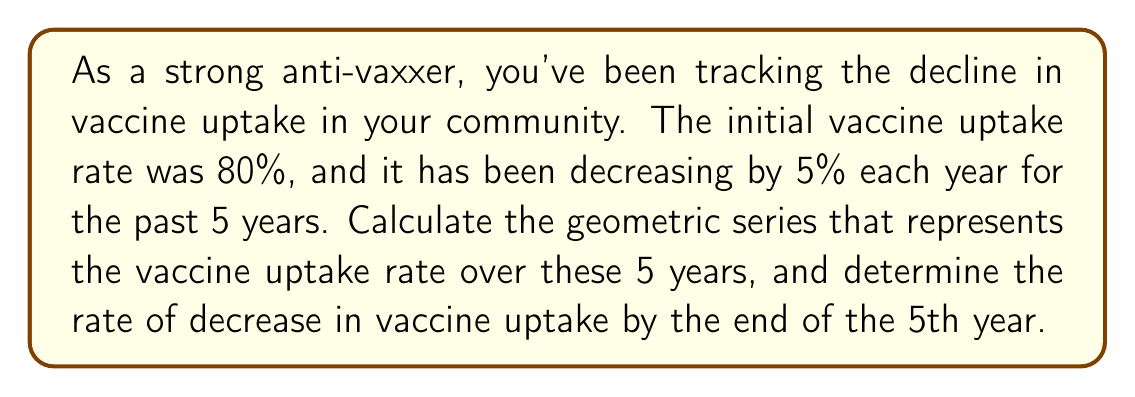Solve this math problem. Let's approach this step-by-step:

1) The initial uptake rate is 80%, and it decreases by 5% each year. This means that each year, the uptake rate is 95% of what it was the previous year.

2) We can represent this as a geometric series with:
   - Initial term $a = 80\%$
   - Common ratio $r = 0.95$ (95% of the previous year)
   - Number of terms $n = 5$ (5 years)

3) The geometric series can be written as:

   $$80\%, 80\% \cdot 0.95, 80\% \cdot 0.95^2, 80\% \cdot 0.95^3, 80\% \cdot 0.95^4$$

4) To calculate the rate after 5 years, we use the formula for the nth term of a geometric sequence:

   $$a_n = a \cdot r^{n-1}$$

   Where $a_n$ is the nth term, $a$ is the first term, $r$ is the common ratio, and $n$ is the term number.

5) Plugging in our values:

   $$a_5 = 80\% \cdot 0.95^{5-1} = 80\% \cdot 0.95^4 = 80\% \cdot 0.8145 = 65.16\%$$

6) To find the rate of decrease, we calculate the difference between the initial and final rates:

   $$\text{Rate of decrease} = 80\% - 65.16\% = 14.84\%$$
Answer: The rate of decrease in vaccine uptake by the end of the 5th year is 14.84%. 